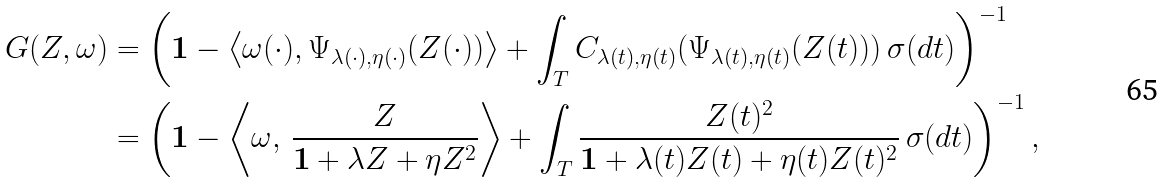Convert formula to latex. <formula><loc_0><loc_0><loc_500><loc_500>G ( Z , \omega ) & = \left ( \mathbf 1 - \left \langle \omega ( \cdot ) , \Psi _ { \lambda ( \cdot ) , \eta ( \cdot ) } ( Z ( \cdot ) ) \right \rangle + \int _ { T } C _ { \lambda ( t ) , \eta ( t ) } ( \Psi _ { \lambda ( t ) , \eta ( t ) } ( Z ( t ) ) ) \, \sigma ( d t ) \right ) ^ { - 1 } \\ & = \left ( \mathbf 1 - \left \langle \omega , \, \frac { Z } { \mathbf 1 + \lambda Z + \eta Z ^ { 2 } } \right \rangle + \int _ { T } \frac { Z ( t ) ^ { 2 } } { \mathbf 1 + \lambda ( t ) Z ( t ) + \eta ( t ) Z ( t ) ^ { 2 } } \, \sigma ( d t ) \right ) ^ { - 1 } ,</formula> 